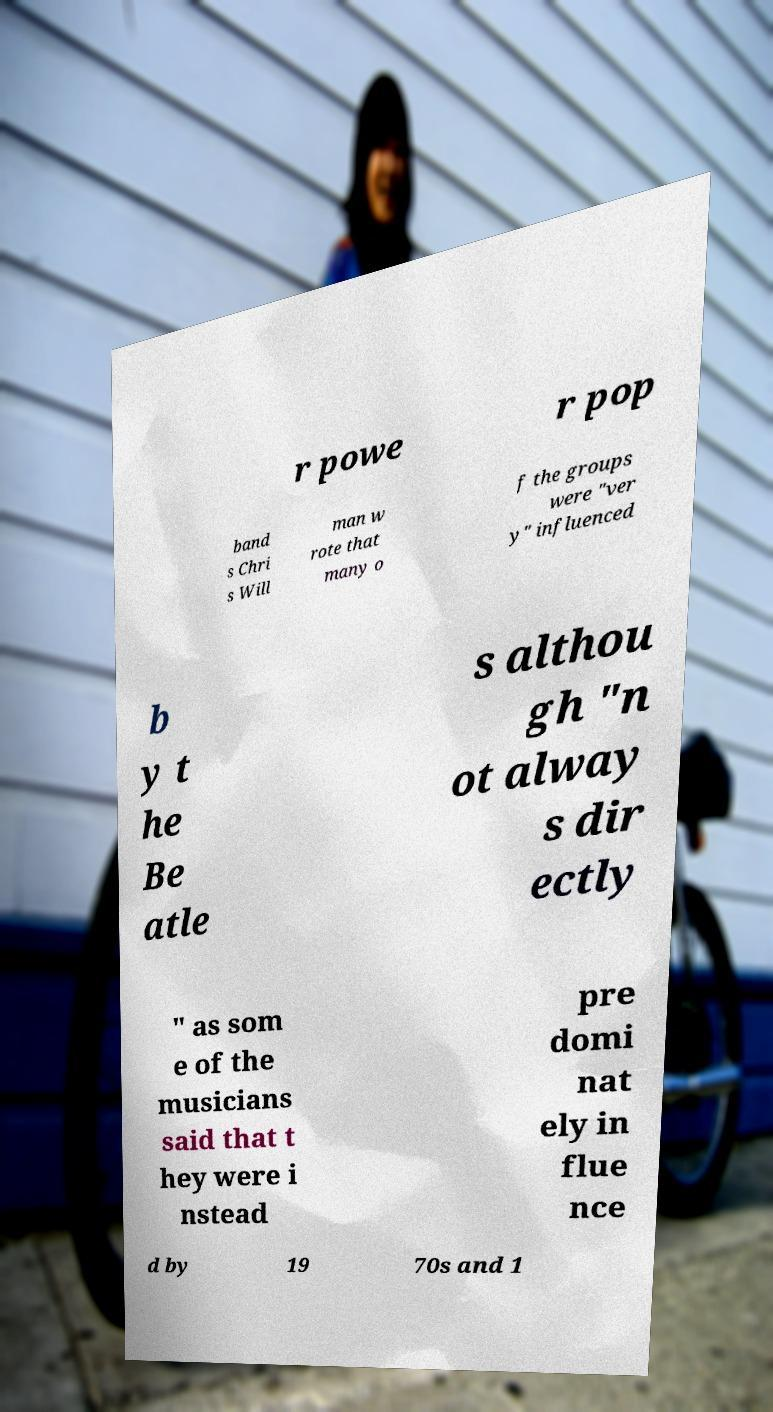Can you read and provide the text displayed in the image?This photo seems to have some interesting text. Can you extract and type it out for me? r powe r pop band s Chri s Will man w rote that many o f the groups were "ver y" influenced b y t he Be atle s althou gh "n ot alway s dir ectly " as som e of the musicians said that t hey were i nstead pre domi nat ely in flue nce d by 19 70s and 1 